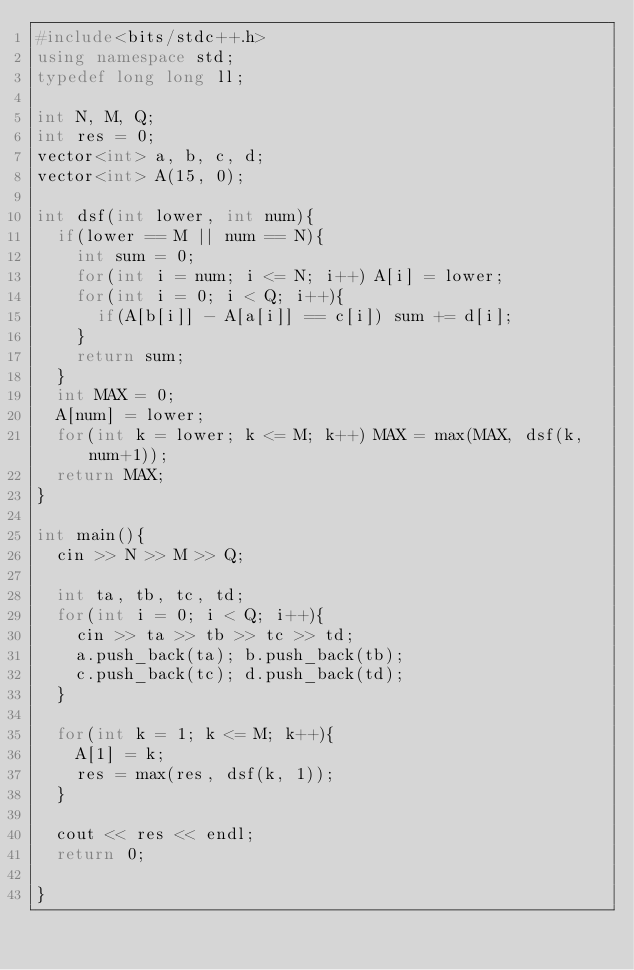<code> <loc_0><loc_0><loc_500><loc_500><_C++_>#include<bits/stdc++.h>
using namespace std;
typedef long long ll;

int N, M, Q;
int res = 0;
vector<int> a, b, c, d;
vector<int> A(15, 0);

int dsf(int lower, int num){
  if(lower == M || num == N){
    int sum = 0;
    for(int i = num; i <= N; i++) A[i] = lower;
    for(int i = 0; i < Q; i++){
      if(A[b[i]] - A[a[i]] == c[i]) sum += d[i];
    }
    return sum;
  }
  int MAX = 0;
  A[num] = lower;
  for(int k = lower; k <= M; k++) MAX = max(MAX, dsf(k, num+1));
  return MAX;
}

int main(){
  cin >> N >> M >> Q;

  int ta, tb, tc, td;
  for(int i = 0; i < Q; i++){
    cin >> ta >> tb >> tc >> td;
    a.push_back(ta); b.push_back(tb);
    c.push_back(tc); d.push_back(td);
  }

  for(int k = 1; k <= M; k++){
    A[1] = k;
    res = max(res, dsf(k, 1));
  }

  cout << res << endl;
  return 0;
  
}</code> 